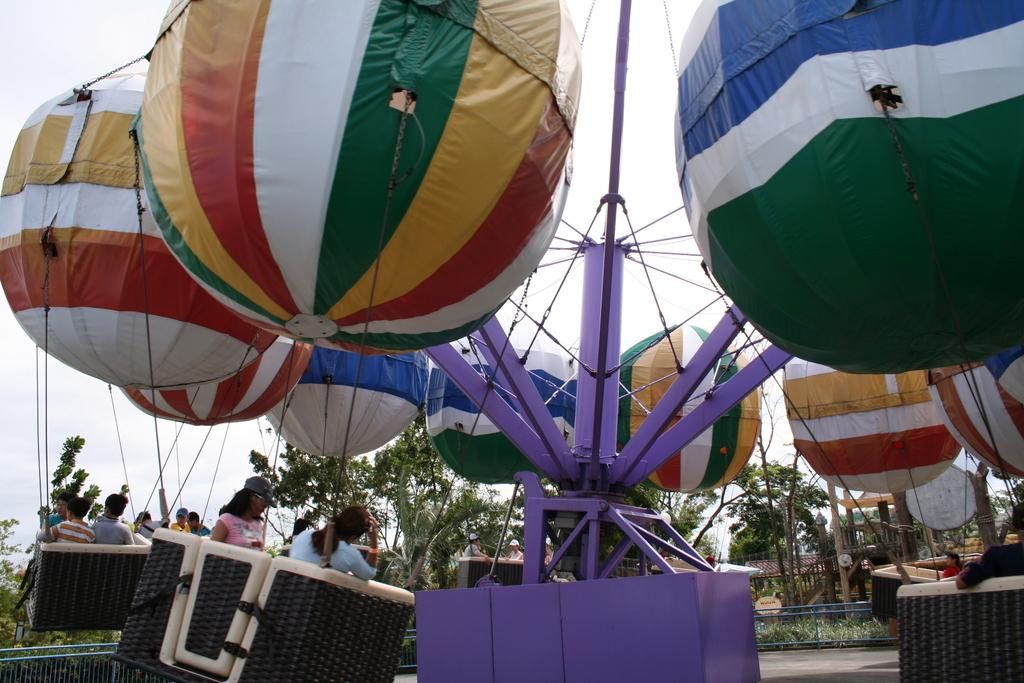What is the main subject of the image? The main subject of the image is hot air balloons. Are there any people in the image? Yes, people are present in the hot air balloons. What can be seen in the background of the image? In the background of the image, there is a fence, a path, grass, trees, and the sky. What type of bell can be heard ringing in the image? There is no bell present in the image, and therefore no sound can be heard. 